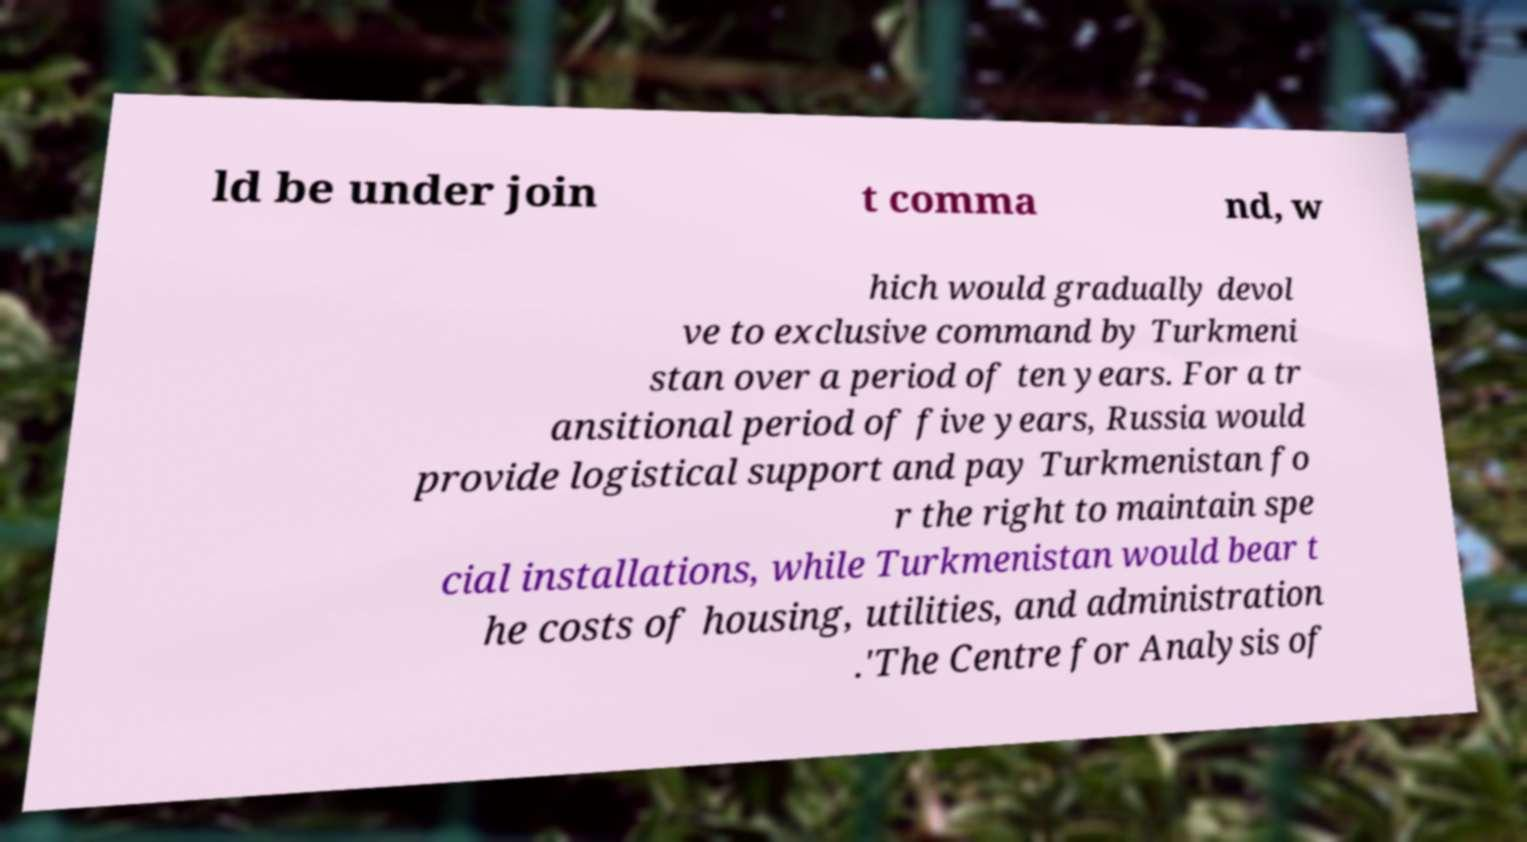Can you read and provide the text displayed in the image?This photo seems to have some interesting text. Can you extract and type it out for me? ld be under join t comma nd, w hich would gradually devol ve to exclusive command by Turkmeni stan over a period of ten years. For a tr ansitional period of five years, Russia would provide logistical support and pay Turkmenistan fo r the right to maintain spe cial installations, while Turkmenistan would bear t he costs of housing, utilities, and administration .'The Centre for Analysis of 